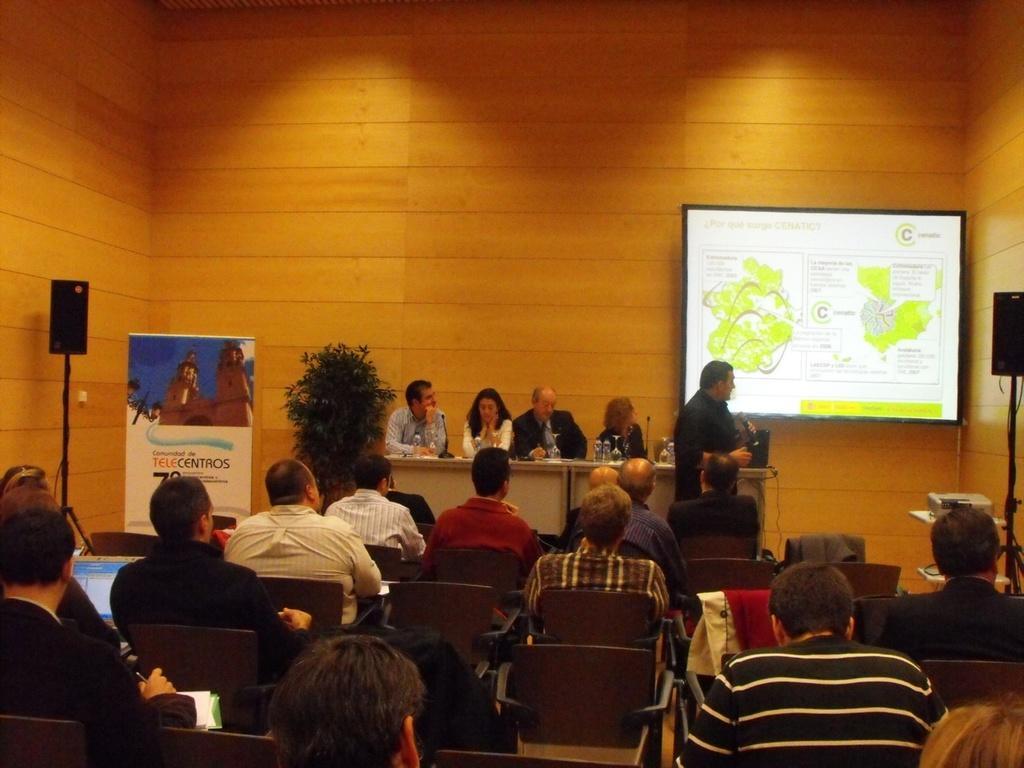Please provide a concise description of this image. In this image I can see number of people sitting on chairs and I can see few books and few laptops in front of them, in the background I can see the speaker, the banner,few people sitting on chair in front of a desk, a person standing and holding a microphone,the projection screen, a projector and the wall. on the table I can see few glasses and few bottles. 